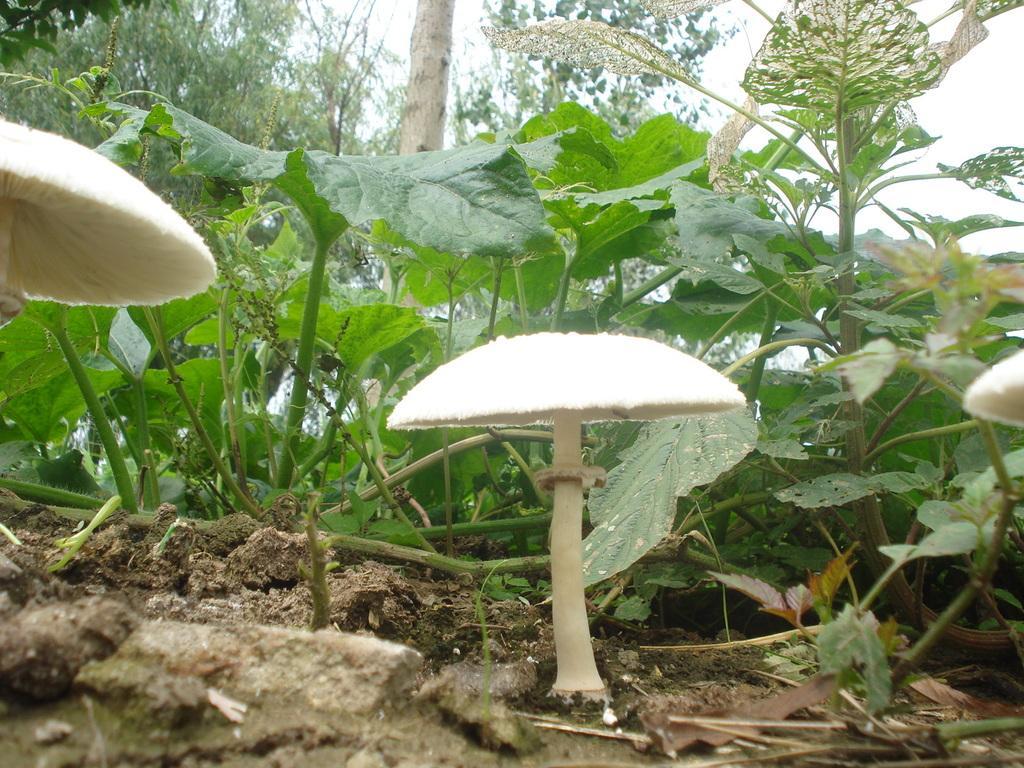How would you summarize this image in a sentence or two? In this image there are mushrooms, plants, trees, sand and the sky. 